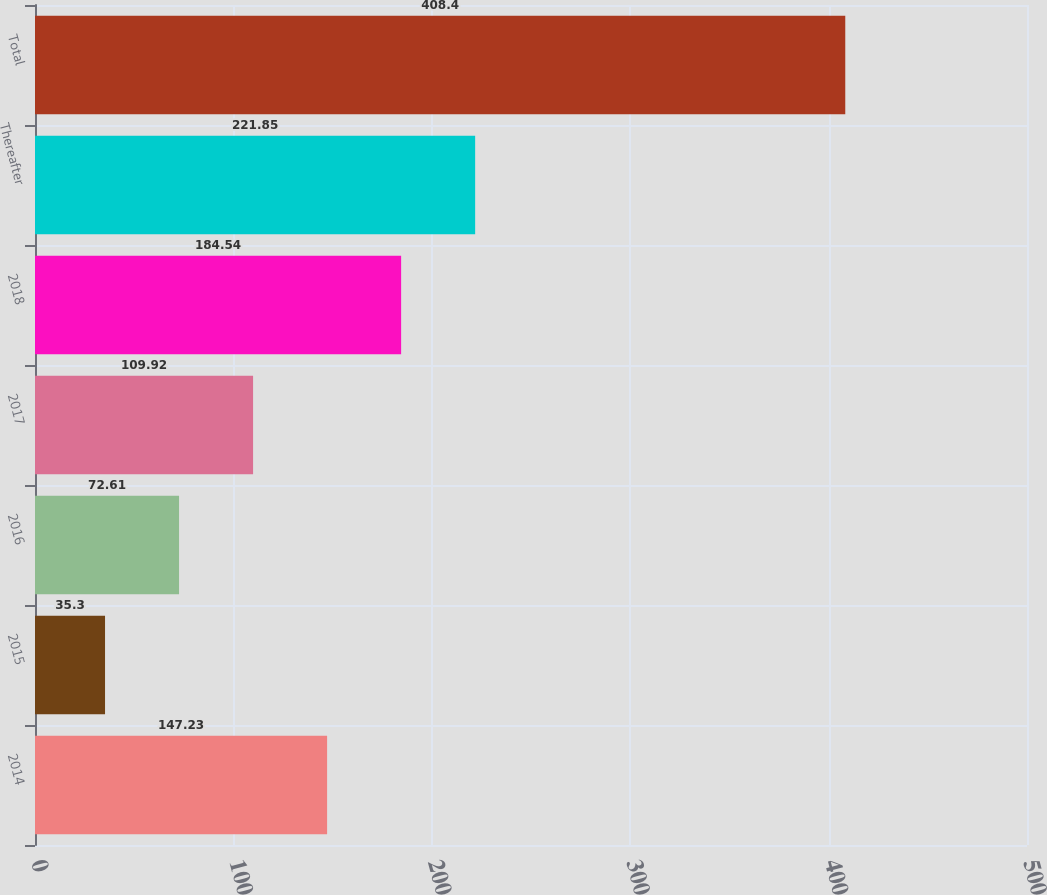<chart> <loc_0><loc_0><loc_500><loc_500><bar_chart><fcel>2014<fcel>2015<fcel>2016<fcel>2017<fcel>2018<fcel>Thereafter<fcel>Total<nl><fcel>147.23<fcel>35.3<fcel>72.61<fcel>109.92<fcel>184.54<fcel>221.85<fcel>408.4<nl></chart> 